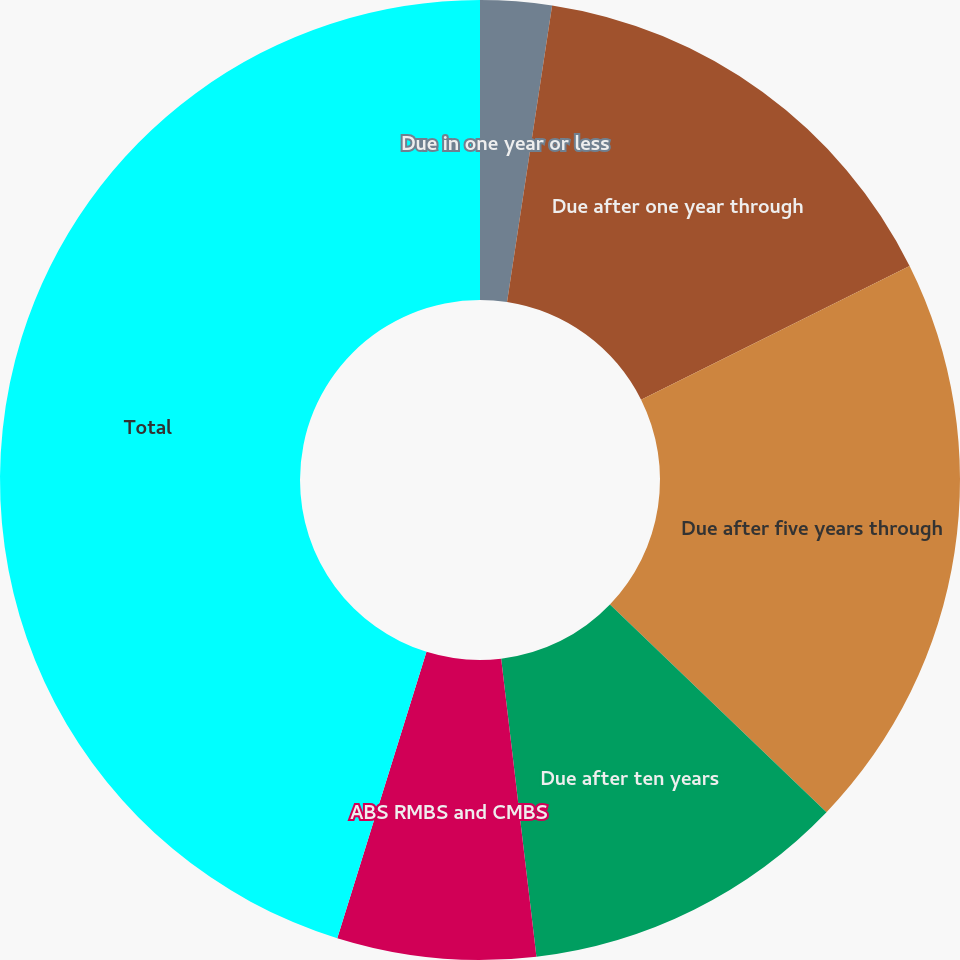Convert chart. <chart><loc_0><loc_0><loc_500><loc_500><pie_chart><fcel>Due in one year or less<fcel>Due after one year through<fcel>Due after five years through<fcel>Due after ten years<fcel>ABS RMBS and CMBS<fcel>Total<nl><fcel>2.4%<fcel>15.24%<fcel>19.52%<fcel>10.96%<fcel>6.68%<fcel>45.19%<nl></chart> 